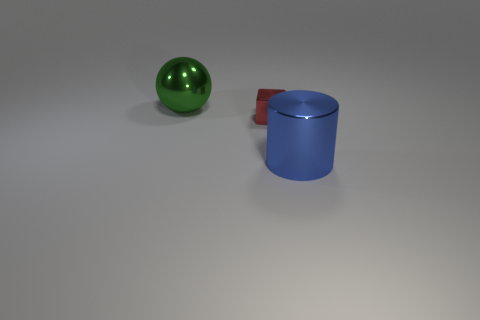Is there any other thing that is the same size as the red metal thing?
Provide a succinct answer. No. There is a big metal object in front of the shiny cube; how many small red metal objects are to the left of it?
Your answer should be compact. 1. There is a blue metallic object; are there any big shiny cylinders on the right side of it?
Your response must be concise. No. What shape is the big object that is in front of the big metallic object left of the large metal cylinder?
Give a very brief answer. Cylinder. Is the number of blue shiny cylinders right of the small red metal cube less than the number of tiny red shiny cubes that are in front of the green thing?
Your response must be concise. No. What number of metal things are behind the big blue cylinder and on the right side of the large metal ball?
Make the answer very short. 1. Is the number of big things that are behind the red thing greater than the number of big green metallic things that are in front of the green metallic ball?
Offer a very short reply. Yes. The blue metal thing is what size?
Ensure brevity in your answer.  Large. There is a large blue object; does it have the same shape as the large object behind the big blue metal thing?
Ensure brevity in your answer.  No. How many blue rubber cylinders are there?
Your response must be concise. 0. 